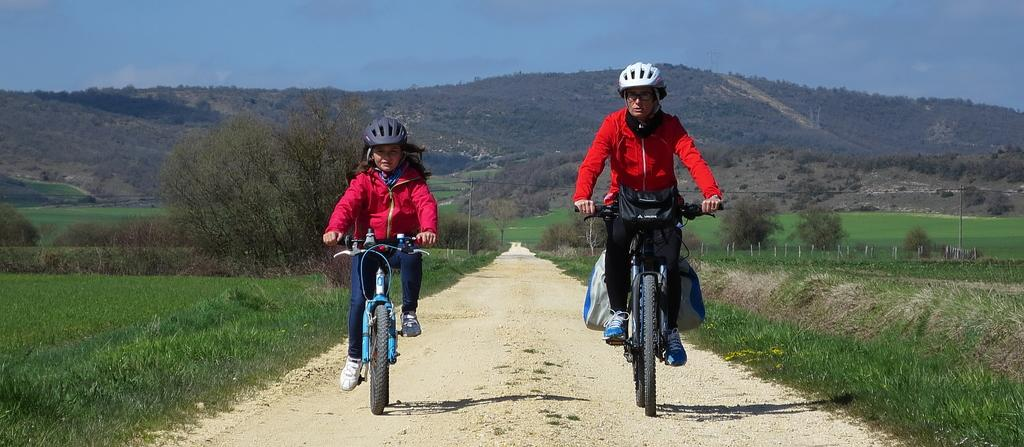How many people are in the image? There are persons in the image. Can you describe the girl in the image? There is a girl in the image. What are the persons and the girl doing in the image? Both the persons and the girl are on cycles. Where are they located in the image? They are on a path. What can be seen on both sides of the path? Grass and plants are visible on both sides of the path. What is visible in the background of the image? The sky is visible in the background of the image. What type of education can be seen being provided in the image? There is no indication of education being provided in the image; it features persons and a girl riding cycles on a path. What type of fruit is being served in the lunchroom in the image? There is no lunchroom present in the image, and therefore no fruit can be seen being served. 